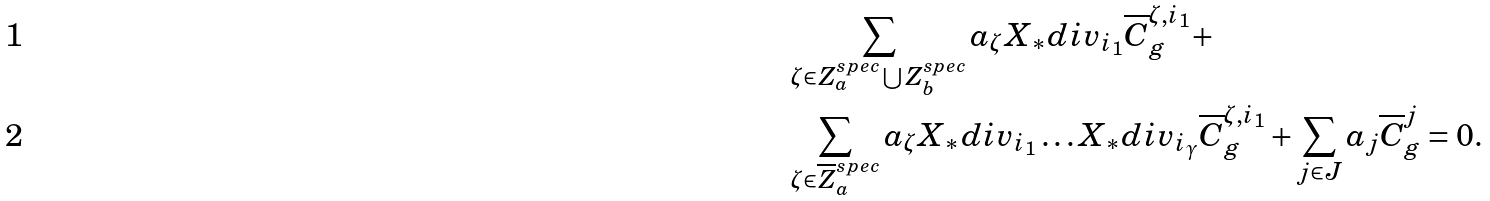Convert formula to latex. <formula><loc_0><loc_0><loc_500><loc_500>& \sum _ { \zeta \in Z _ { a } ^ { s p e c } \bigcup Z _ { b } ^ { s p e c } } a _ { \zeta } X _ { * } d i v _ { i _ { 1 } } \overline { C } ^ { \zeta , i _ { 1 } } _ { g } + \\ & \sum _ { \zeta \in \overline { Z } ^ { s p e c } _ { a } } a _ { \zeta } X _ { * } d i v _ { i _ { 1 } } \dots X _ { * } d i v _ { i _ { \gamma } } \overline { C } ^ { \zeta , i _ { 1 } } _ { g } + \sum _ { j \in J } a _ { j } \overline { C } ^ { j } _ { g } = 0 .</formula> 